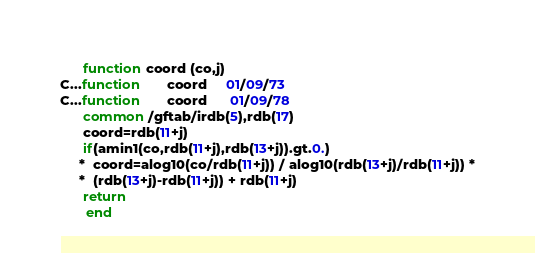Convert code to text. <code><loc_0><loc_0><loc_500><loc_500><_FORTRAN_>      function coord (co,j)
C...function       coord     01/09/73
C...function       coord      01/09/78
      common /gftab/irdb(5),rdb(17)
      coord=rdb(11+j)
      if(amin1(co,rdb(11+j),rdb(13+j)).gt.0.)
     *  coord=alog10(co/rdb(11+j)) / alog10(rdb(13+j)/rdb(11+j)) *
     *  (rdb(13+j)-rdb(11+j)) + rdb(11+j)
      return
       end
</code> 